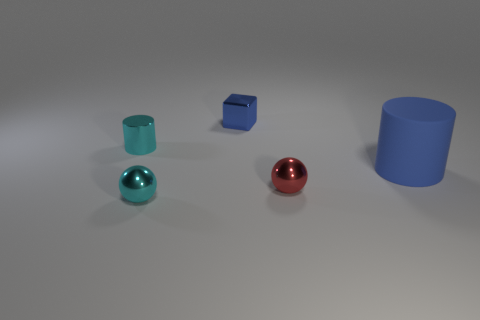There is a cyan metallic thing in front of the large blue rubber cylinder; does it have the same shape as the blue rubber thing in front of the tiny cyan shiny cylinder?
Keep it short and to the point. No. What is the shape of the blue object that is the same size as the metal cylinder?
Your answer should be compact. Cube. How many metal objects are either small cyan cylinders or green things?
Your response must be concise. 1. Do the tiny cylinder that is to the left of the large blue rubber object and the sphere that is behind the cyan shiny ball have the same material?
Keep it short and to the point. Yes. What color is the cylinder that is made of the same material as the block?
Keep it short and to the point. Cyan. Are there more large blue matte things that are on the left side of the blue matte thing than spheres behind the cyan cylinder?
Your answer should be compact. No. Are there any metallic cubes?
Make the answer very short. Yes. There is a object that is the same color as the small cube; what is it made of?
Your answer should be very brief. Rubber. How many things are either small spheres or metal objects?
Provide a succinct answer. 4. Are there any tiny cubes of the same color as the big matte thing?
Provide a short and direct response. Yes. 